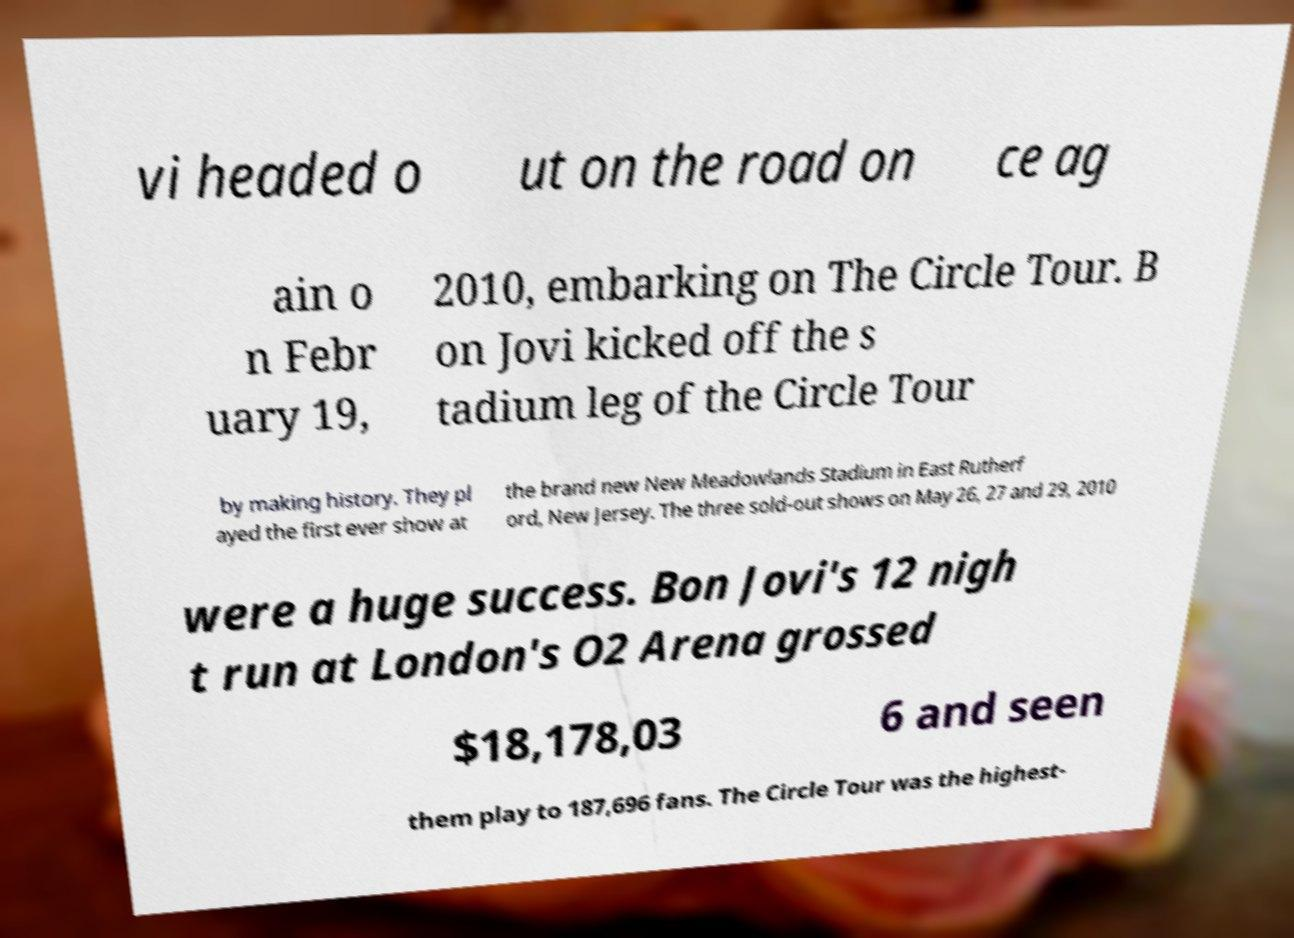Please read and relay the text visible in this image. What does it say? vi headed o ut on the road on ce ag ain o n Febr uary 19, 2010, embarking on The Circle Tour. B on Jovi kicked off the s tadium leg of the Circle Tour by making history. They pl ayed the first ever show at the brand new New Meadowlands Stadium in East Rutherf ord, New Jersey. The three sold-out shows on May 26, 27 and 29, 2010 were a huge success. Bon Jovi's 12 nigh t run at London's O2 Arena grossed $18,178,03 6 and seen them play to 187,696 fans. The Circle Tour was the highest- 